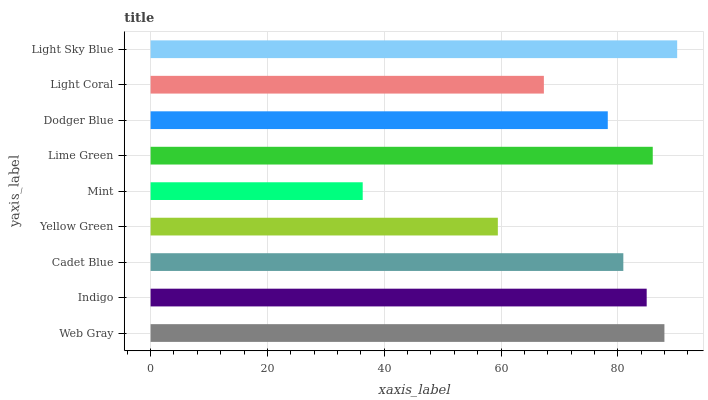Is Mint the minimum?
Answer yes or no. Yes. Is Light Sky Blue the maximum?
Answer yes or no. Yes. Is Indigo the minimum?
Answer yes or no. No. Is Indigo the maximum?
Answer yes or no. No. Is Web Gray greater than Indigo?
Answer yes or no. Yes. Is Indigo less than Web Gray?
Answer yes or no. Yes. Is Indigo greater than Web Gray?
Answer yes or no. No. Is Web Gray less than Indigo?
Answer yes or no. No. Is Cadet Blue the high median?
Answer yes or no. Yes. Is Cadet Blue the low median?
Answer yes or no. Yes. Is Yellow Green the high median?
Answer yes or no. No. Is Dodger Blue the low median?
Answer yes or no. No. 